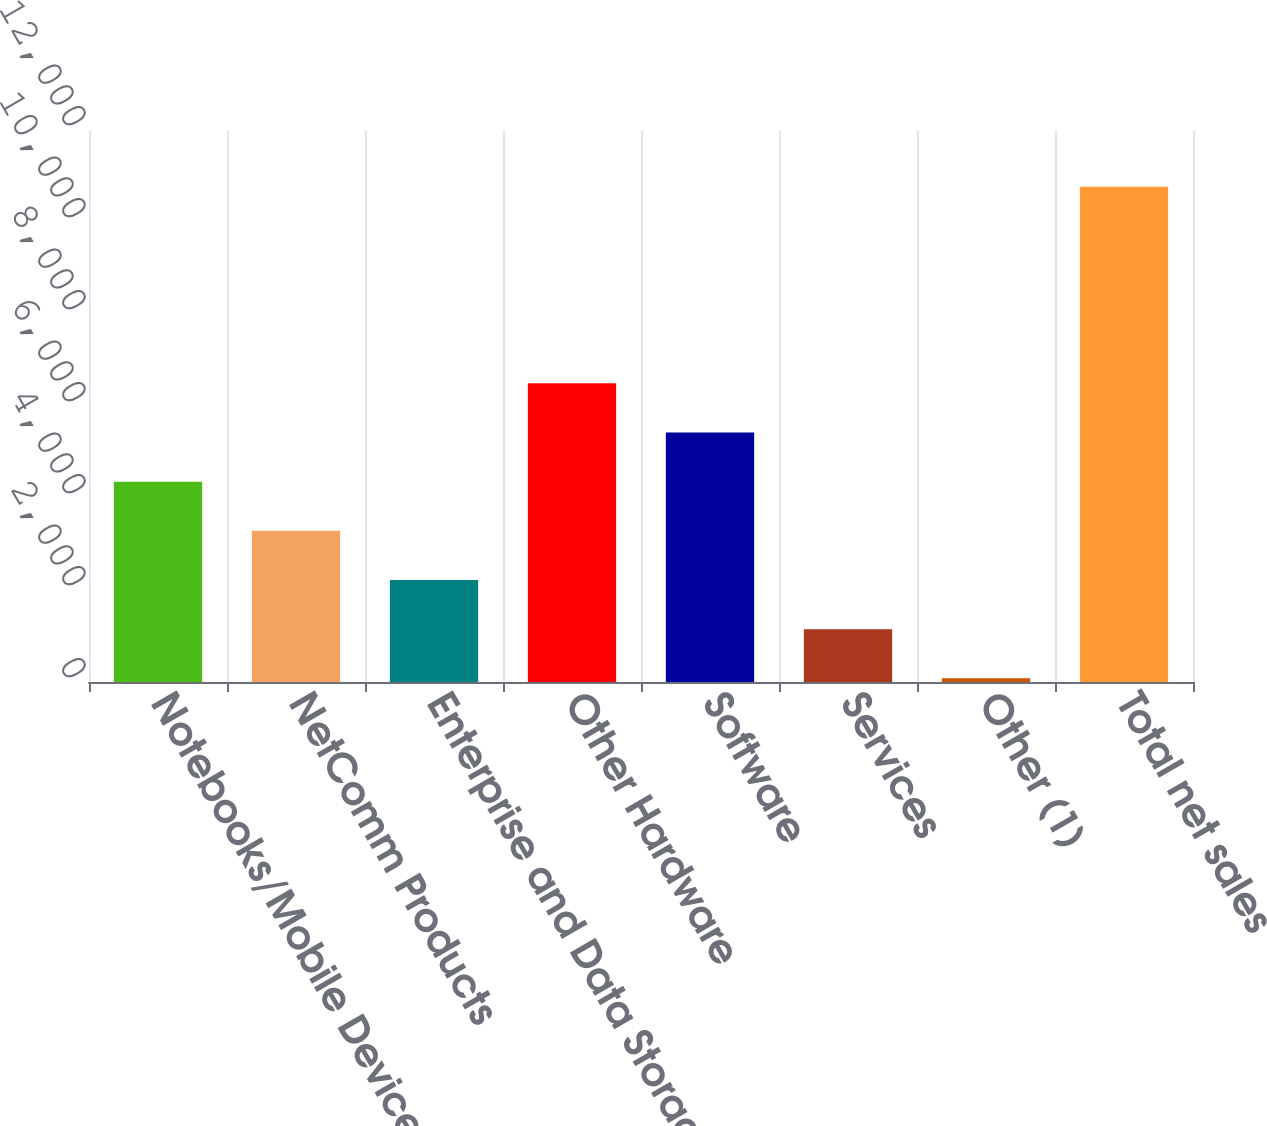Convert chart to OTSL. <chart><loc_0><loc_0><loc_500><loc_500><bar_chart><fcel>Notebooks/Mobile Devices<fcel>NetComm Products<fcel>Enterprise and Data Storage<fcel>Other Hardware<fcel>Software<fcel>Services<fcel>Other (1)<fcel>Total net sales<nl><fcel>4355.68<fcel>3286.86<fcel>2218.04<fcel>6493.32<fcel>5424.5<fcel>1149.22<fcel>80.4<fcel>10768.6<nl></chart> 